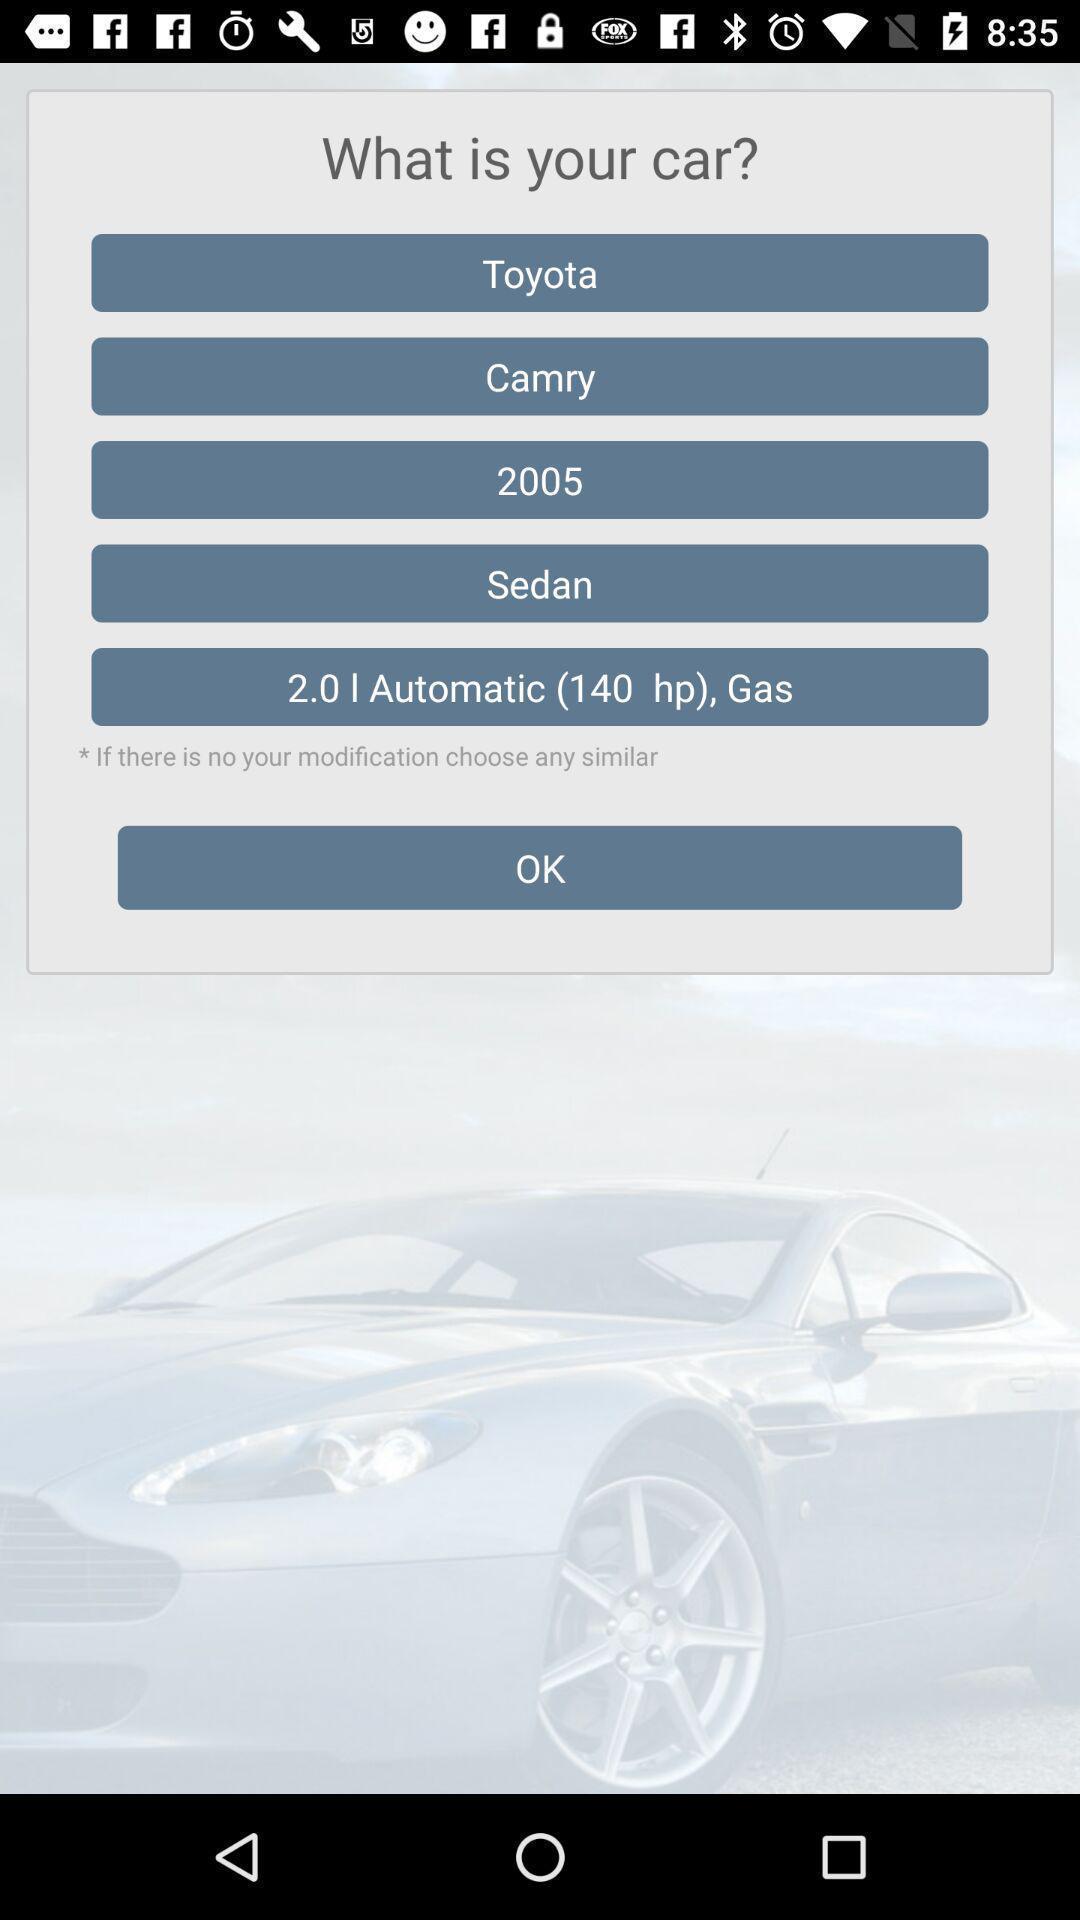What is the overall content of this screenshot? Screen showing question with multiple options. 